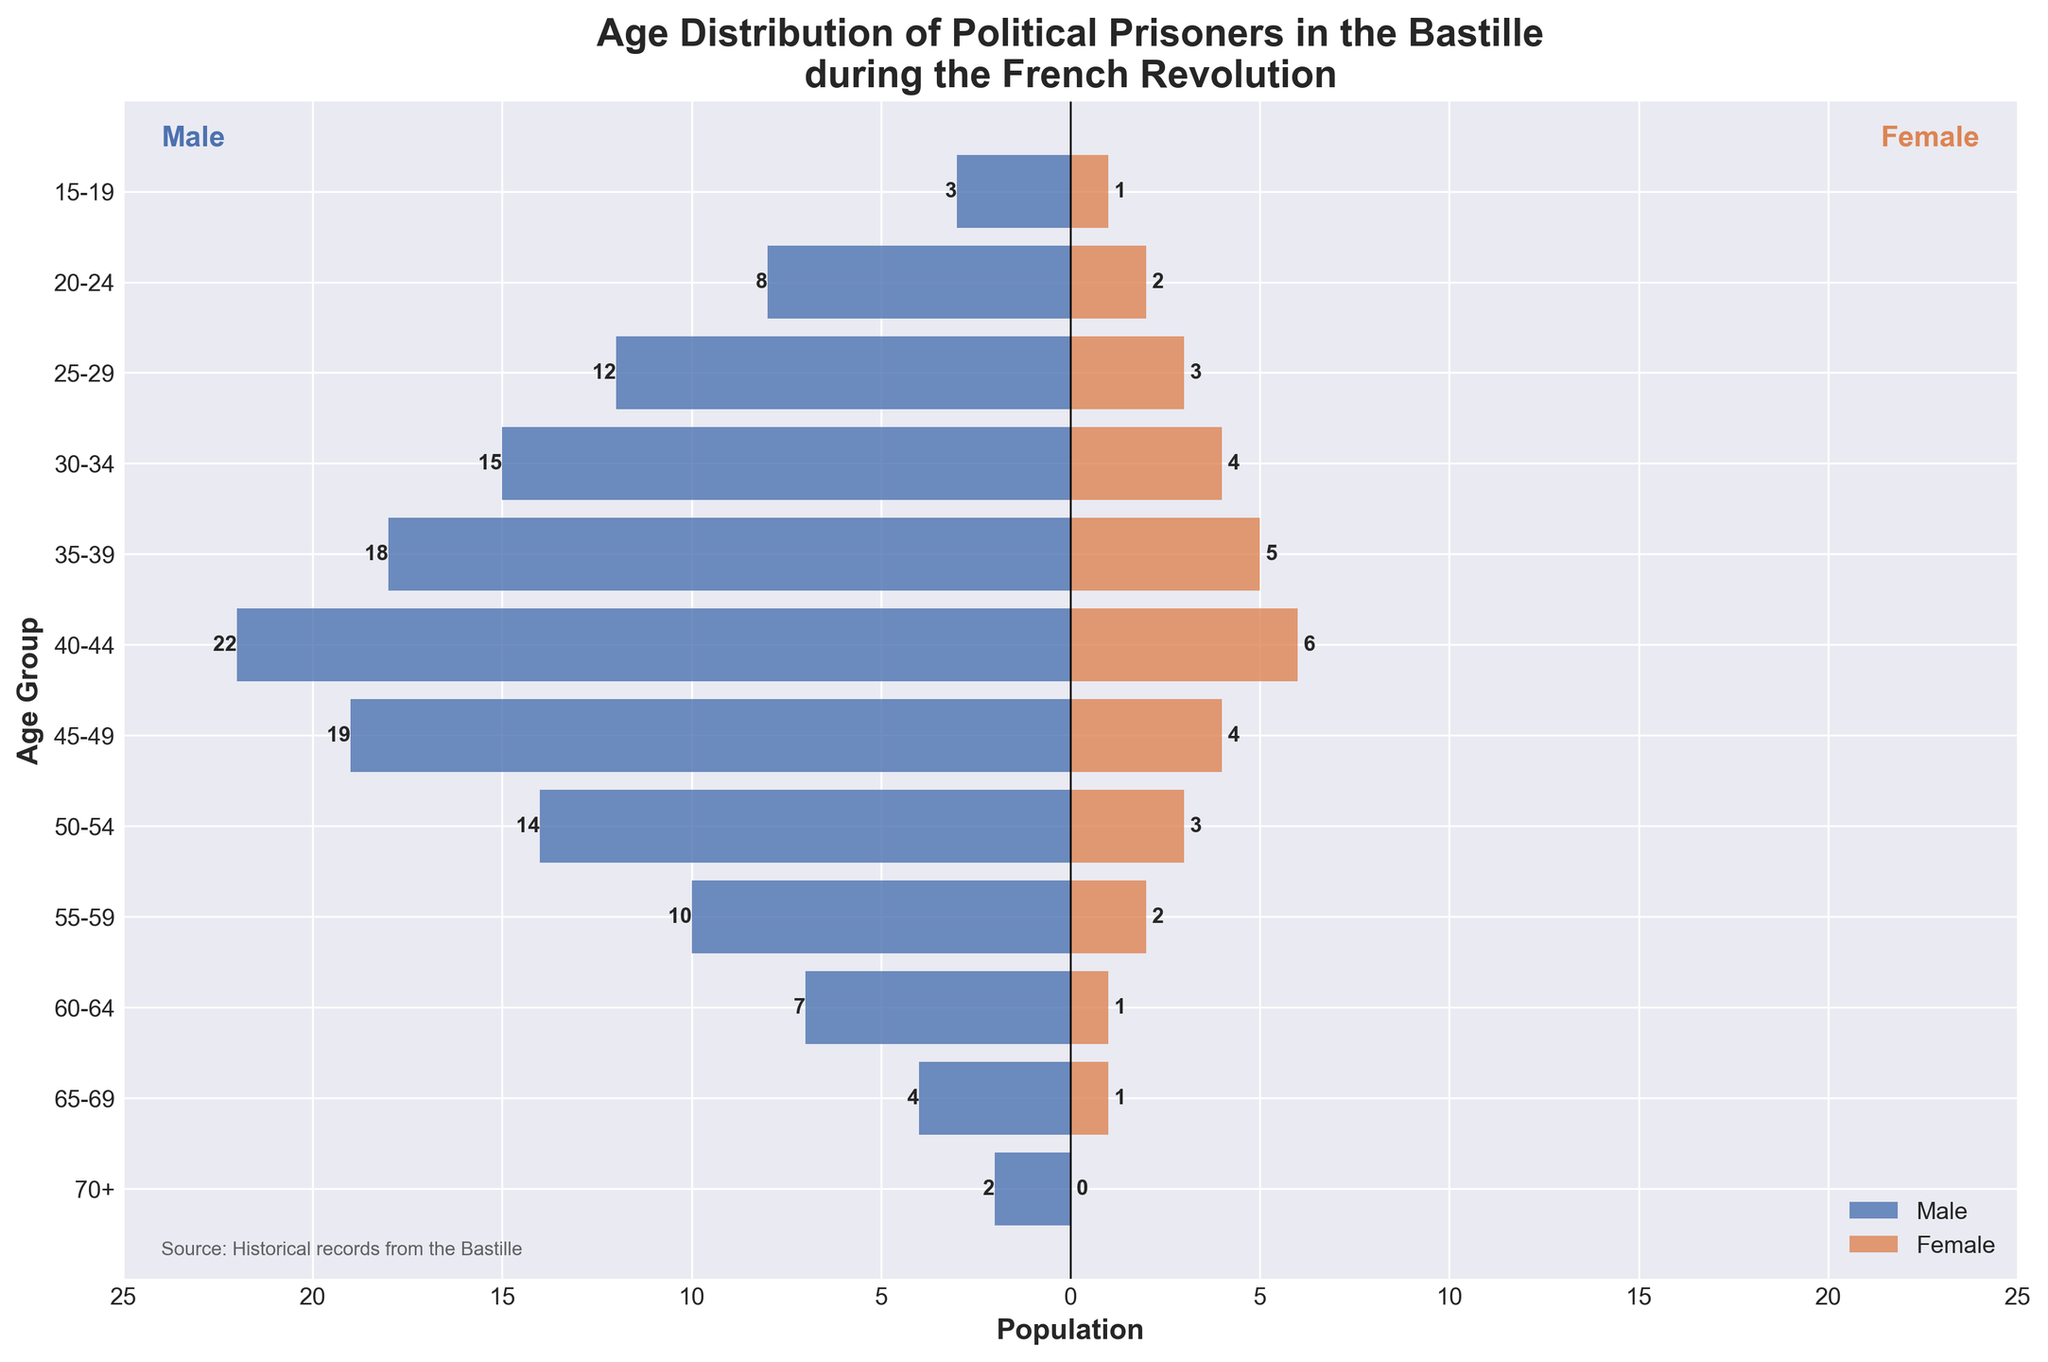What's the title of the plot? The title is located at the top of the plot and reads: "Age Distribution of Political Prisoners in the Bastille during the French Revolution."
Answer: Age Distribution of Political Prisoners in the Bastille during the French Revolution How many age groups are represented in the plot? Count the number of labeled age groups on the y-axis, which represent different age ranges from 15-19 to 70+. There are 12 such groups.
Answer: 12 Which age group has the highest number of male prisoners? Look at the length of the blue bars, which represent male prisoners, and identify the longest one. The longest bar for males is in the 40-44 age group.
Answer: 40-44 What is the difference between the number of male and female prisoners in the 30-34 age group? For the 30-34 age group, the number of male prisoners is 15 and the number of female prisoners is 4. The difference is 15 - 4 = 11.
Answer: 11 What is the total number of prisoners (both male and female) aged 50-54? Add the number of male prisoners (14) and female prisoners (3) in the 50-54 age group. The total is 14 + 3 = 17.
Answer: 17 Which age group has an equal number of male and female prisoners? Compare the lengths of the blue (male) and orange (female) bars for each age group. The 70+ age group is the only one where the lengths of both bars are the same, indicating no female prisoners and 2 male prisoners.
Answer: 70+ In what age group is the gender imbalance (difference between male and female prisoners) the highest? Calculate the difference between male and female prisoners in each group and find the maximum. The 40-44 age group has 22 males and 6 females, leading to a difference of 16, which is the highest.
Answer: 40-44 What is the percentage of female prisoners in the 55-59 age group? There are 10 male and 2 female prisoners in the 55-59 group. The total is 10 + 2 = 12. The percentage of female prisoners is (2 / 12) * 100 = 16.67%.
Answer: 16.67% How many age groups have more than 10 male prisoners? Identify age groups where the blue bar representing male prisoners exceeds 10 units. They are 25-29, 30-34, 35-39, 40-44, and 45-49, summing to 5 groups.
Answer: 5 Which age group has the smallest population of prisoners of both genders combined? Compare the total length of bars (both blue for males and orange for females) across all age groups. The smallest total length is in the 70+ age group, with 2 males and 0 females for a total of 2 prisoners.
Answer: 70+ 